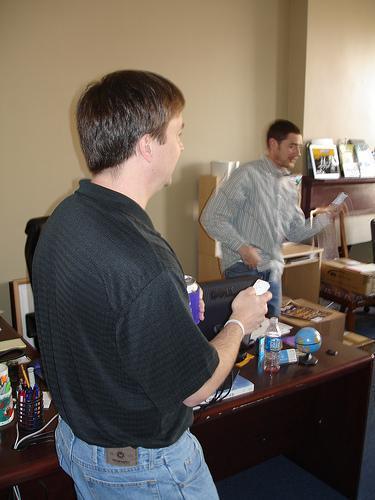How many men are in the photo?
Give a very brief answer. 2. 